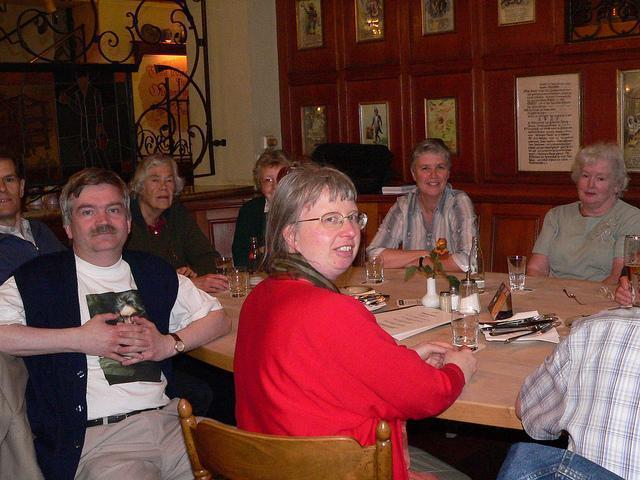What age class do most people here belong to?
Indicate the correct response by choosing from the four available options to answer the question.
Options: Middle age, seniors, juniors, youth. Seniors. 